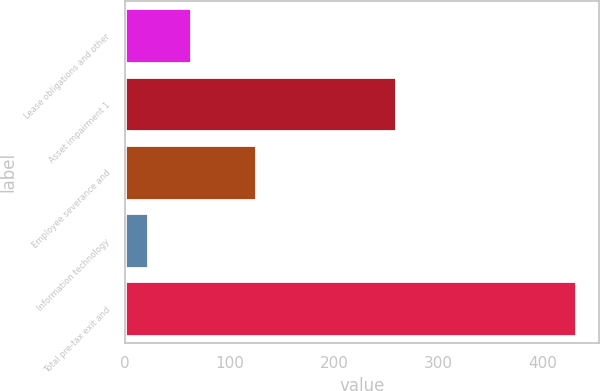<chart> <loc_0><loc_0><loc_500><loc_500><bar_chart><fcel>Lease obligations and other<fcel>Asset impairment 1<fcel>Employee severance and<fcel>Information technology<fcel>Total pre-tax exit and<nl><fcel>63<fcel>260<fcel>125<fcel>22<fcel>432<nl></chart> 